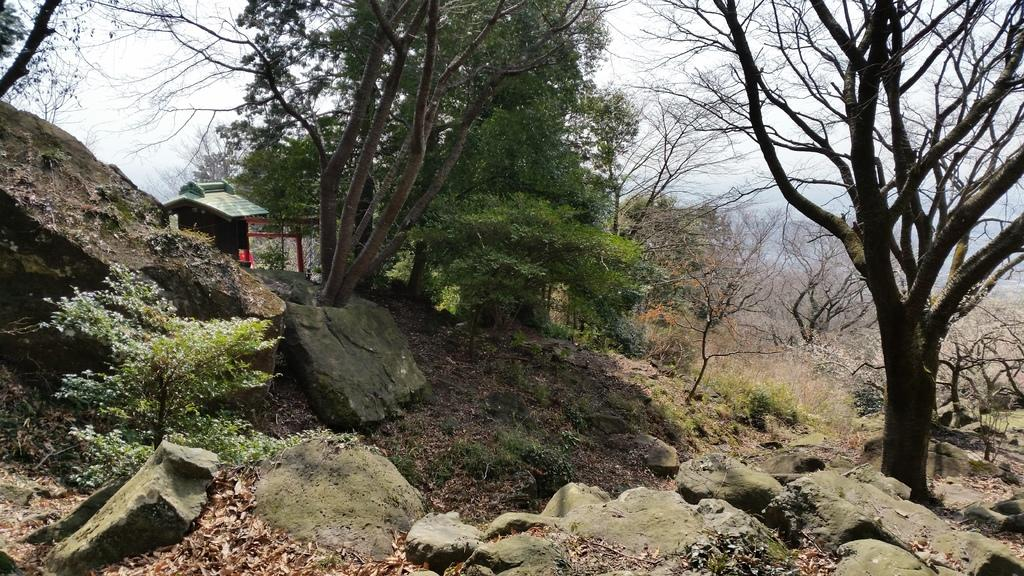What type of vegetation can be seen in the image? There are trees and plants in the image. What other natural elements are present in the image? There are rocks in the image. What is on the ground in the image? Leaves are present on the ground in the image. What can be seen in the background of the image? There is sky visible in the background of the image. What type of screw can be seen in the image? There is no screw present in the image; it features trees, plants, rocks, leaves, and sky. What type of pleasure can be seen in the image? The image does not depict any specific pleasure or emotion; it is a scene of nature. 